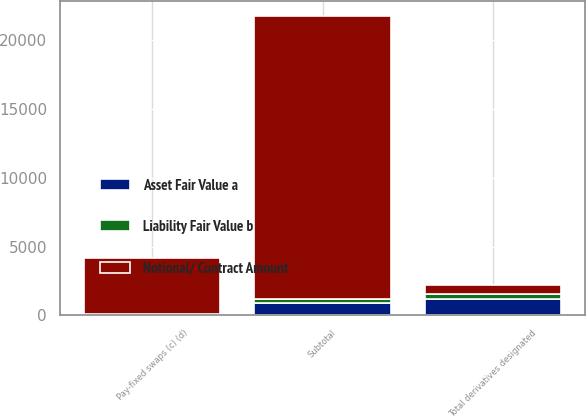Convert chart to OTSL. <chart><loc_0><loc_0><loc_500><loc_500><stacked_bar_chart><ecel><fcel>Pay-fixed swaps (c) (d)<fcel>Subtotal<fcel>Total derivatives designated<nl><fcel>Notional/ Contract Amount<fcel>4076<fcel>20522<fcel>644.5<nl><fcel>Asset Fair Value a<fcel>54<fcel>925<fcel>1189<nl><fcel>Liability Fair Value b<fcel>66<fcel>296<fcel>364<nl></chart> 